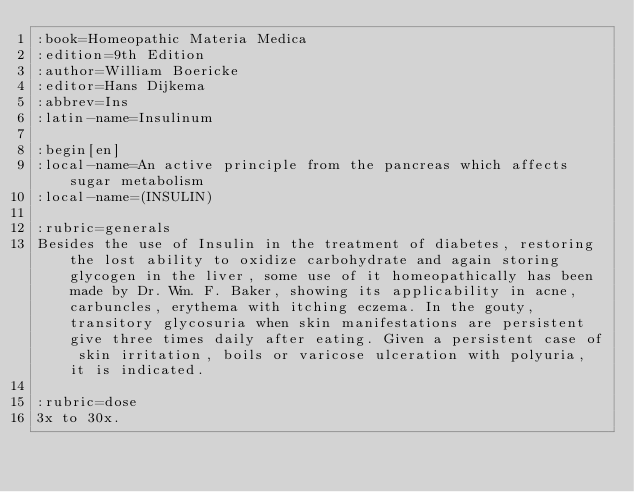Convert code to text. <code><loc_0><loc_0><loc_500><loc_500><_ObjectiveC_>:book=Homeopathic Materia Medica
:edition=9th Edition
:author=William Boericke
:editor=Hans Dijkema
:abbrev=Ins
:latin-name=Insulinum

:begin[en]
:local-name=An active principle from the pancreas which affects sugar metabolism
:local-name=(INSULIN)

:rubric=generals
Besides the use of Insulin in the treatment of diabetes, restoring the lost ability to oxidize carbohydrate and again storing glycogen in the liver, some use of it homeopathically has been made by Dr. Wm. F. Baker, showing its applicability in acne, carbuncles, erythema with itching eczema. In the gouty, transitory glycosuria when skin manifestations are persistent give three times daily after eating. Given a persistent case of skin irritation, boils or varicose ulceration with polyuria, it is indicated.

:rubric=dose
3x to 30x.

</code> 